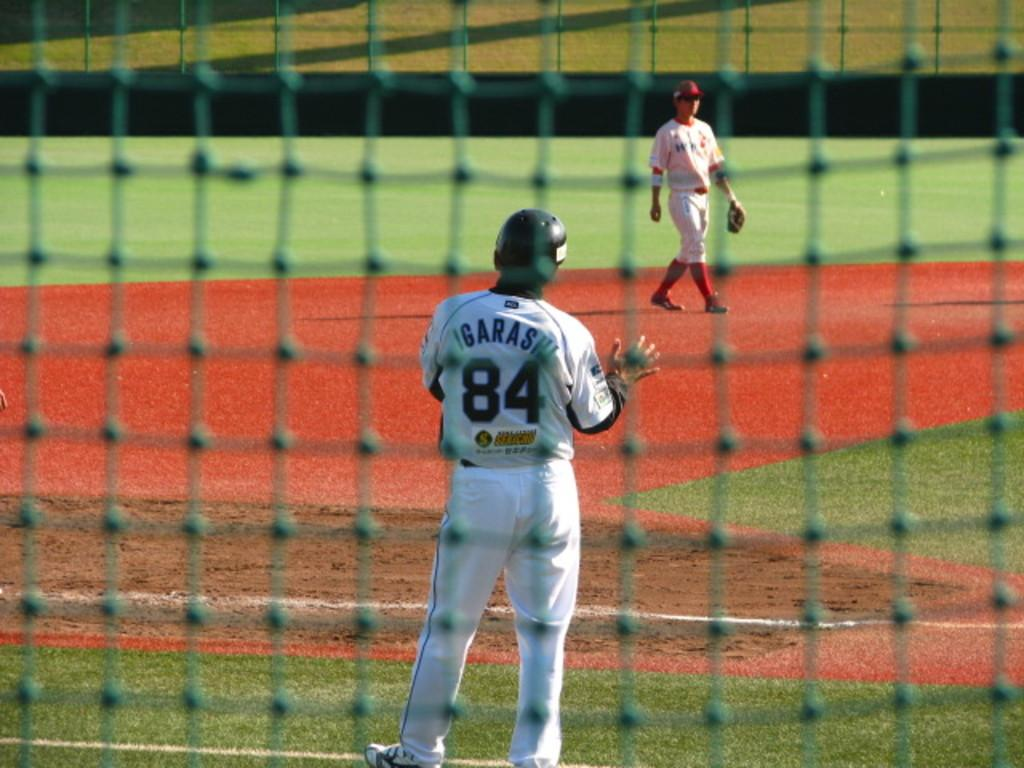<image>
Provide a brief description of the given image. A baseball player called Igarashi wears a white strip and waits for the ball to be thrown to him. 